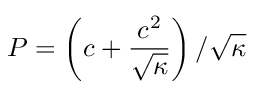Convert formula to latex. <formula><loc_0><loc_0><loc_500><loc_500>P = \left ( c + \frac { c ^ { 2 } } { \sqrt { \kappa } } \right ) / \sqrt { \kappa }</formula> 